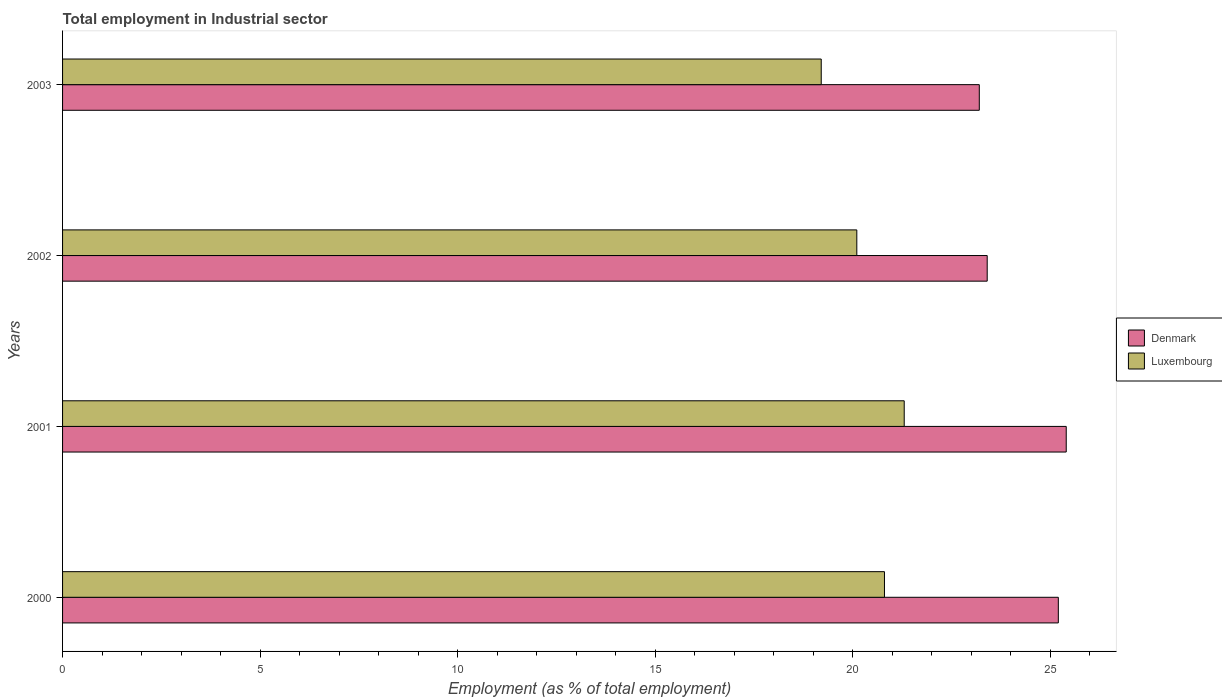How many different coloured bars are there?
Keep it short and to the point. 2. How many groups of bars are there?
Keep it short and to the point. 4. Are the number of bars per tick equal to the number of legend labels?
Keep it short and to the point. Yes. How many bars are there on the 2nd tick from the top?
Keep it short and to the point. 2. How many bars are there on the 1st tick from the bottom?
Offer a terse response. 2. What is the label of the 3rd group of bars from the top?
Give a very brief answer. 2001. What is the employment in industrial sector in Denmark in 2002?
Your answer should be very brief. 23.4. Across all years, what is the maximum employment in industrial sector in Denmark?
Offer a terse response. 25.4. Across all years, what is the minimum employment in industrial sector in Denmark?
Provide a succinct answer. 23.2. In which year was the employment in industrial sector in Luxembourg minimum?
Provide a succinct answer. 2003. What is the total employment in industrial sector in Luxembourg in the graph?
Ensure brevity in your answer.  81.4. What is the difference between the employment in industrial sector in Luxembourg in 2001 and that in 2003?
Your response must be concise. 2.1. What is the average employment in industrial sector in Luxembourg per year?
Offer a very short reply. 20.35. In the year 2002, what is the difference between the employment in industrial sector in Luxembourg and employment in industrial sector in Denmark?
Offer a very short reply. -3.3. In how many years, is the employment in industrial sector in Luxembourg greater than 5 %?
Ensure brevity in your answer.  4. What is the ratio of the employment in industrial sector in Luxembourg in 2000 to that in 2002?
Provide a succinct answer. 1.03. Is the employment in industrial sector in Luxembourg in 2002 less than that in 2003?
Give a very brief answer. No. What is the difference between the highest and the second highest employment in industrial sector in Denmark?
Keep it short and to the point. 0.2. What is the difference between the highest and the lowest employment in industrial sector in Luxembourg?
Give a very brief answer. 2.1. What does the 1st bar from the top in 2002 represents?
Ensure brevity in your answer.  Luxembourg. What does the 1st bar from the bottom in 2002 represents?
Offer a terse response. Denmark. Are all the bars in the graph horizontal?
Offer a very short reply. Yes. Are the values on the major ticks of X-axis written in scientific E-notation?
Your response must be concise. No. Where does the legend appear in the graph?
Offer a very short reply. Center right. What is the title of the graph?
Provide a succinct answer. Total employment in Industrial sector. What is the label or title of the X-axis?
Your response must be concise. Employment (as % of total employment). What is the label or title of the Y-axis?
Your response must be concise. Years. What is the Employment (as % of total employment) of Denmark in 2000?
Your answer should be compact. 25.2. What is the Employment (as % of total employment) of Luxembourg in 2000?
Ensure brevity in your answer.  20.8. What is the Employment (as % of total employment) of Denmark in 2001?
Your answer should be very brief. 25.4. What is the Employment (as % of total employment) of Luxembourg in 2001?
Give a very brief answer. 21.3. What is the Employment (as % of total employment) in Denmark in 2002?
Ensure brevity in your answer.  23.4. What is the Employment (as % of total employment) of Luxembourg in 2002?
Make the answer very short. 20.1. What is the Employment (as % of total employment) of Denmark in 2003?
Your answer should be very brief. 23.2. What is the Employment (as % of total employment) in Luxembourg in 2003?
Your response must be concise. 19.2. Across all years, what is the maximum Employment (as % of total employment) of Denmark?
Offer a very short reply. 25.4. Across all years, what is the maximum Employment (as % of total employment) of Luxembourg?
Make the answer very short. 21.3. Across all years, what is the minimum Employment (as % of total employment) of Denmark?
Make the answer very short. 23.2. Across all years, what is the minimum Employment (as % of total employment) in Luxembourg?
Keep it short and to the point. 19.2. What is the total Employment (as % of total employment) of Denmark in the graph?
Your response must be concise. 97.2. What is the total Employment (as % of total employment) of Luxembourg in the graph?
Provide a succinct answer. 81.4. What is the difference between the Employment (as % of total employment) in Denmark in 2000 and that in 2001?
Your answer should be compact. -0.2. What is the difference between the Employment (as % of total employment) of Denmark in 2000 and that in 2002?
Offer a terse response. 1.8. What is the difference between the Employment (as % of total employment) in Luxembourg in 2000 and that in 2002?
Ensure brevity in your answer.  0.7. What is the difference between the Employment (as % of total employment) in Denmark in 2000 and that in 2003?
Your answer should be compact. 2. What is the difference between the Employment (as % of total employment) of Luxembourg in 2001 and that in 2002?
Ensure brevity in your answer.  1.2. What is the difference between the Employment (as % of total employment) of Denmark in 2001 and that in 2003?
Offer a very short reply. 2.2. What is the difference between the Employment (as % of total employment) of Luxembourg in 2001 and that in 2003?
Offer a very short reply. 2.1. What is the difference between the Employment (as % of total employment) in Denmark in 2002 and that in 2003?
Offer a terse response. 0.2. What is the difference between the Employment (as % of total employment) in Luxembourg in 2002 and that in 2003?
Your response must be concise. 0.9. What is the difference between the Employment (as % of total employment) in Denmark in 2001 and the Employment (as % of total employment) in Luxembourg in 2002?
Offer a terse response. 5.3. What is the difference between the Employment (as % of total employment) of Denmark in 2001 and the Employment (as % of total employment) of Luxembourg in 2003?
Offer a terse response. 6.2. What is the difference between the Employment (as % of total employment) of Denmark in 2002 and the Employment (as % of total employment) of Luxembourg in 2003?
Provide a short and direct response. 4.2. What is the average Employment (as % of total employment) of Denmark per year?
Make the answer very short. 24.3. What is the average Employment (as % of total employment) in Luxembourg per year?
Give a very brief answer. 20.35. In the year 2000, what is the difference between the Employment (as % of total employment) of Denmark and Employment (as % of total employment) of Luxembourg?
Give a very brief answer. 4.4. In the year 2002, what is the difference between the Employment (as % of total employment) in Denmark and Employment (as % of total employment) in Luxembourg?
Offer a terse response. 3.3. In the year 2003, what is the difference between the Employment (as % of total employment) of Denmark and Employment (as % of total employment) of Luxembourg?
Give a very brief answer. 4. What is the ratio of the Employment (as % of total employment) of Luxembourg in 2000 to that in 2001?
Give a very brief answer. 0.98. What is the ratio of the Employment (as % of total employment) of Denmark in 2000 to that in 2002?
Provide a succinct answer. 1.08. What is the ratio of the Employment (as % of total employment) in Luxembourg in 2000 to that in 2002?
Give a very brief answer. 1.03. What is the ratio of the Employment (as % of total employment) of Denmark in 2000 to that in 2003?
Provide a succinct answer. 1.09. What is the ratio of the Employment (as % of total employment) in Luxembourg in 2000 to that in 2003?
Your answer should be compact. 1.08. What is the ratio of the Employment (as % of total employment) in Denmark in 2001 to that in 2002?
Keep it short and to the point. 1.09. What is the ratio of the Employment (as % of total employment) in Luxembourg in 2001 to that in 2002?
Provide a succinct answer. 1.06. What is the ratio of the Employment (as % of total employment) of Denmark in 2001 to that in 2003?
Your answer should be very brief. 1.09. What is the ratio of the Employment (as % of total employment) of Luxembourg in 2001 to that in 2003?
Offer a very short reply. 1.11. What is the ratio of the Employment (as % of total employment) in Denmark in 2002 to that in 2003?
Your response must be concise. 1.01. What is the ratio of the Employment (as % of total employment) of Luxembourg in 2002 to that in 2003?
Your answer should be compact. 1.05. What is the difference between the highest and the lowest Employment (as % of total employment) of Denmark?
Provide a short and direct response. 2.2. What is the difference between the highest and the lowest Employment (as % of total employment) in Luxembourg?
Provide a succinct answer. 2.1. 